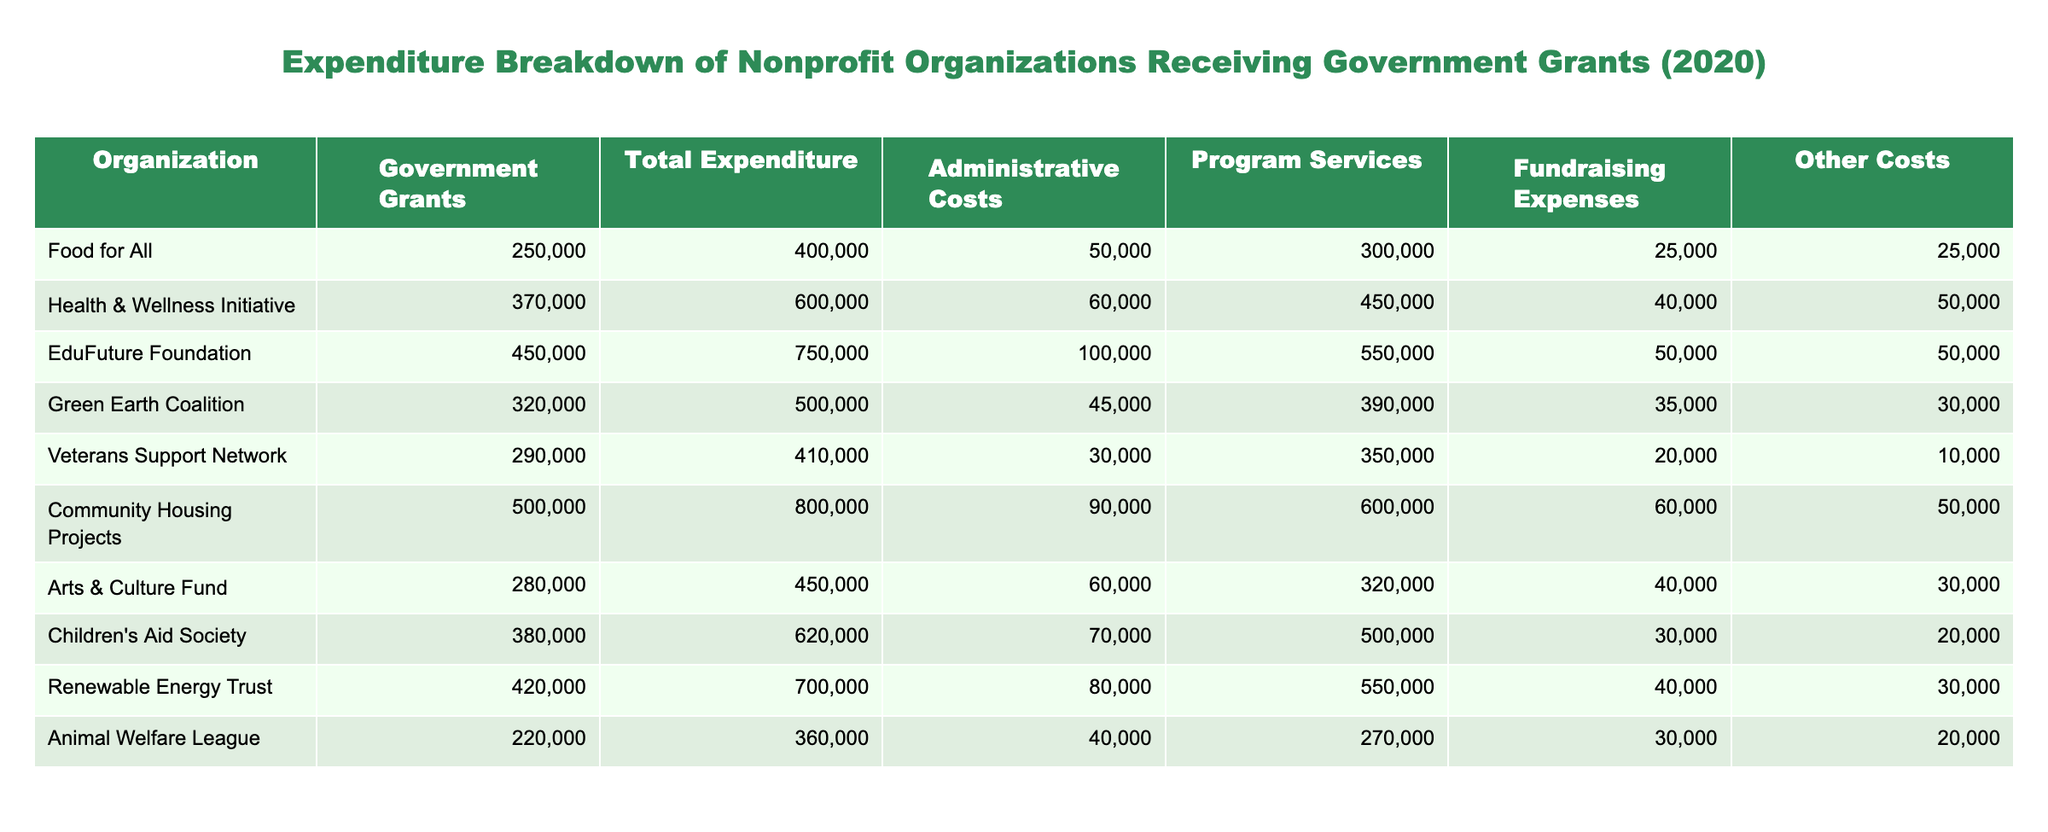What is the total expenditure of the Community Housing Projects? The table lists the total expenditure for each organization. For Community Housing Projects, the total expenditure is explicitly given as 800,000.
Answer: 800,000 Which organization has the highest amount allocated for program services? By looking at the "Program Services" column, the EduFuture Foundation has the highest amount at 550,000, compared to other organizations.
Answer: EduFuture Foundation What is the average administrative cost of all organizations? To find the average, we sum the administrative costs (50,000 + 60,000 + 100,000 + 45,000 + 30,000 + 90,000 + 60,000 + 70,000 + 80,000 + 40,000) = 625,000. There are 10 organizations, so the average is 625,000 / 10 = 62,500.
Answer: 62,500 Is the total expenditure of the Health & Wellness Initiative greater than 500,000? The total expenditure for the Health & Wellness Initiative is listed as 600,000, which is indeed greater than 500,000.
Answer: Yes What is the difference between the total expenditure and government grants for the Animal Welfare League? For the Animal Welfare League, total expenditure is 360,000 and government grants are 220,000. The difference is 360,000 - 220,000 = 140,000.
Answer: 140,000 Which organization has the lowest fundraising expenses? Looking at the "Fundraising Expenses" column, the Veterans Support Network has the lowest amount at 20,000.
Answer: Veterans Support Network If we combine the fundraising expenses of the Green Earth Coalition and the Arts & Culture Fund, what will the total be? The fundraising expenses for the Green Earth Coalition is 35,000, and for the Arts & Culture Fund, it is 40,000. Summing these gives 35,000 + 40,000 = 75,000.
Answer: 75,000 Are more than half of the organizations listed receiving government grants of over 300,000? There are 10 organizations in total, and 6 of them (Health & Wellness Initiative, EduFuture Foundation, Community Housing Projects, Children's Aid Society, Renewable Energy Trust, and Food for All) are receiving government grants over 300,000. Since 6 is more than half of 10, the answer is yes.
Answer: Yes What is the total of "Other Costs" for all organizations? To calculate the total of "Other Costs," sum them as follows: 25,000 + 50,000 + 50,000 + 30,000 + 10,000 + 50,000 + 30,000 + 20,000 + 30,000 + 20,000 = 315,000.
Answer: 315,000 